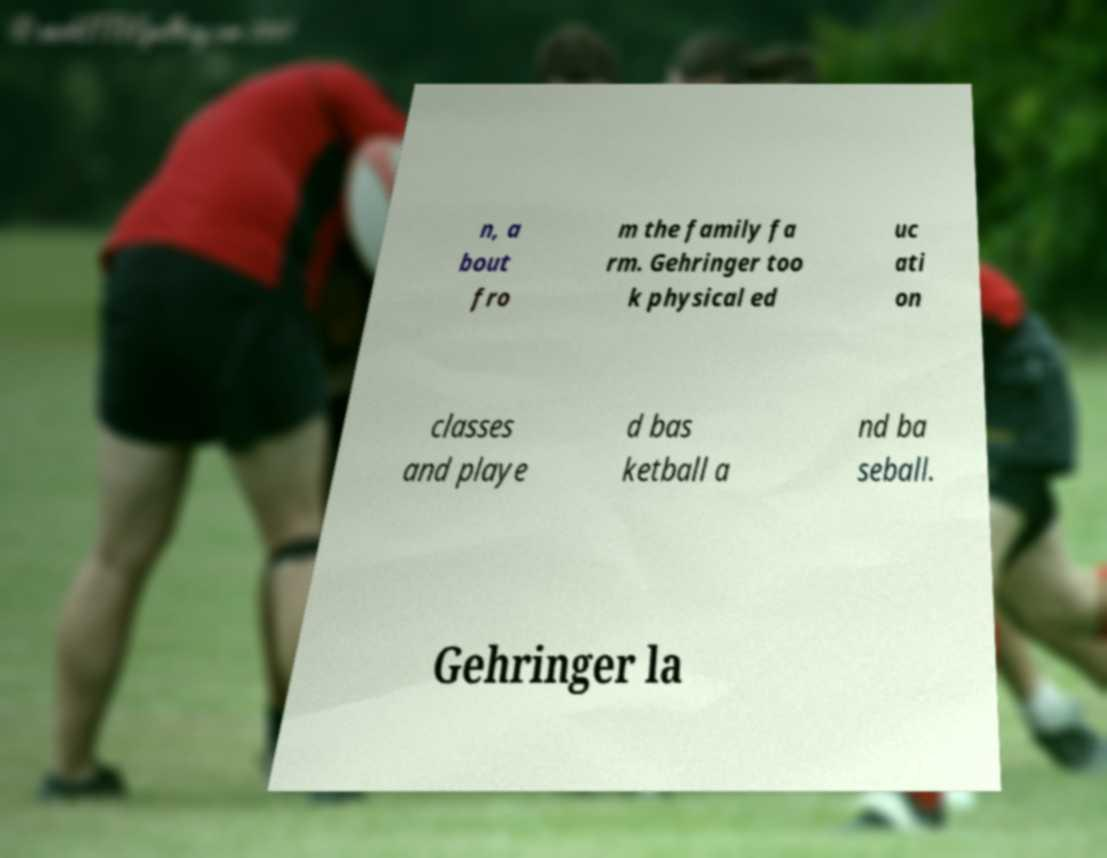Can you accurately transcribe the text from the provided image for me? n, a bout fro m the family fa rm. Gehringer too k physical ed uc ati on classes and playe d bas ketball a nd ba seball. Gehringer la 